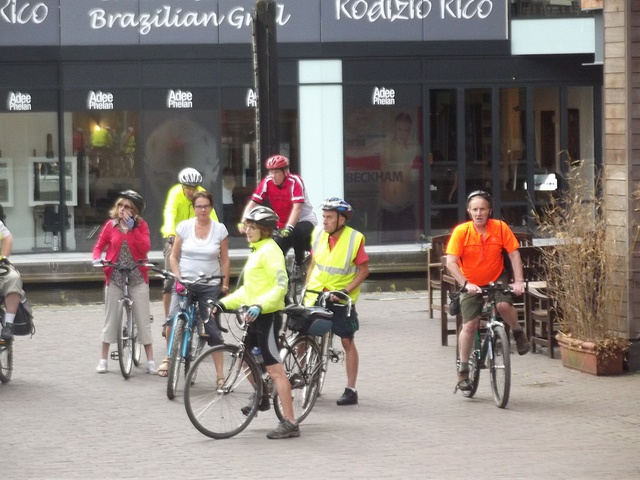Describe the objects in this image and their specific colors. I can see potted plant in gray, tan, and black tones, people in gray, red, and black tones, people in gray, beige, khaki, and black tones, people in gray, darkgray, and brown tones, and people in gray, yellow, black, brown, and beige tones in this image. 